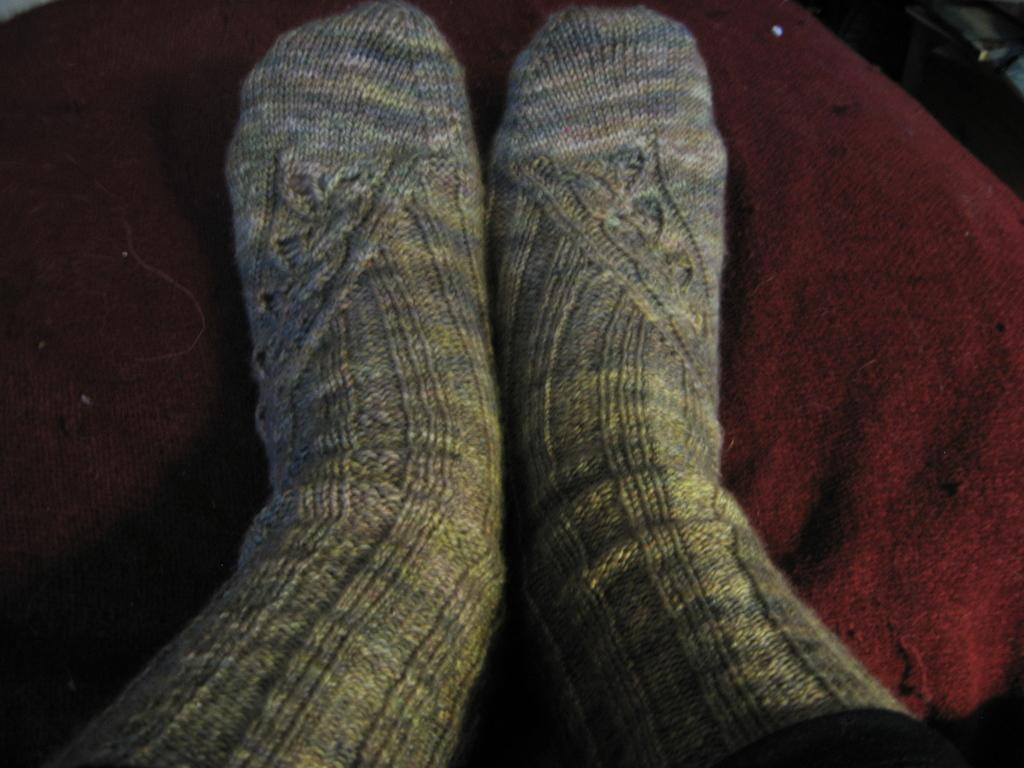What part of a person's body is visible in the image? A person's legs are visible in the image. What type of clothing is the person wearing on their legs? The person is wearing socks. What is the person's legs placed on in the image? The person's legs are placed on a cloth. What time of day is it in the image, and is the person a police officer? The time of day is not mentioned in the image, and there is no indication that the person is a police officer. How is the person's digestion process being affected by the cloth they are resting their legs on? There is no information about the person's digestion process in the image, nor is there any indication that the cloth has any impact on it. 